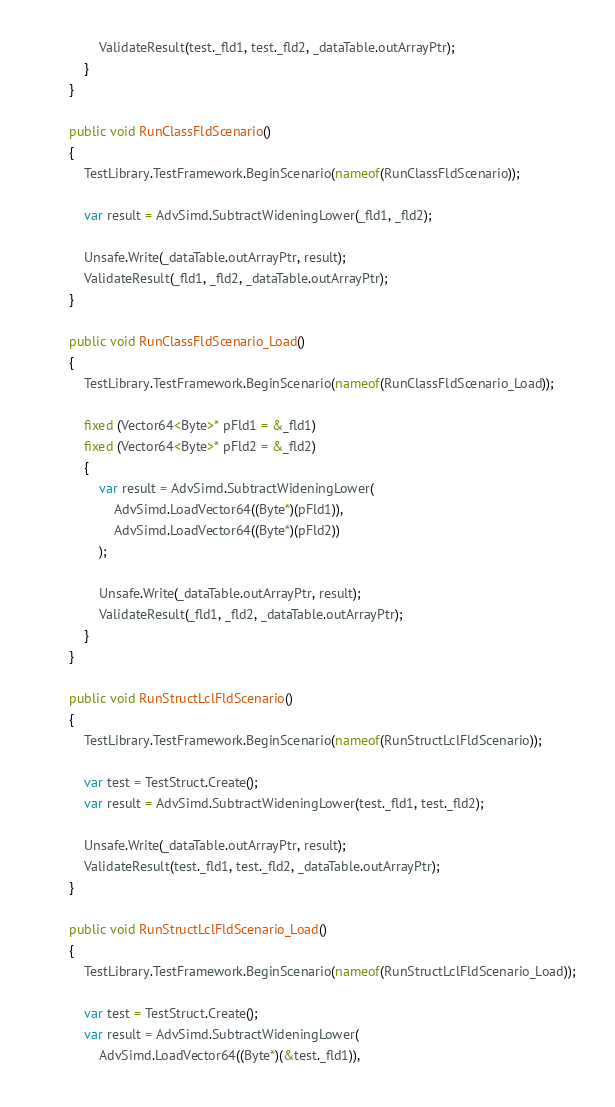Convert code to text. <code><loc_0><loc_0><loc_500><loc_500><_C#_>                ValidateResult(test._fld1, test._fld2, _dataTable.outArrayPtr);
            }
        }

        public void RunClassFldScenario()
        {
            TestLibrary.TestFramework.BeginScenario(nameof(RunClassFldScenario));

            var result = AdvSimd.SubtractWideningLower(_fld1, _fld2);

            Unsafe.Write(_dataTable.outArrayPtr, result);
            ValidateResult(_fld1, _fld2, _dataTable.outArrayPtr);
        }

        public void RunClassFldScenario_Load()
        {
            TestLibrary.TestFramework.BeginScenario(nameof(RunClassFldScenario_Load));

            fixed (Vector64<Byte>* pFld1 = &_fld1)
            fixed (Vector64<Byte>* pFld2 = &_fld2)
            {
                var result = AdvSimd.SubtractWideningLower(
                    AdvSimd.LoadVector64((Byte*)(pFld1)),
                    AdvSimd.LoadVector64((Byte*)(pFld2))
                );

                Unsafe.Write(_dataTable.outArrayPtr, result);
                ValidateResult(_fld1, _fld2, _dataTable.outArrayPtr);
            }
        }

        public void RunStructLclFldScenario()
        {
            TestLibrary.TestFramework.BeginScenario(nameof(RunStructLclFldScenario));

            var test = TestStruct.Create();
            var result = AdvSimd.SubtractWideningLower(test._fld1, test._fld2);

            Unsafe.Write(_dataTable.outArrayPtr, result);
            ValidateResult(test._fld1, test._fld2, _dataTable.outArrayPtr);
        }

        public void RunStructLclFldScenario_Load()
        {
            TestLibrary.TestFramework.BeginScenario(nameof(RunStructLclFldScenario_Load));

            var test = TestStruct.Create();
            var result = AdvSimd.SubtractWideningLower(
                AdvSimd.LoadVector64((Byte*)(&test._fld1)),</code> 